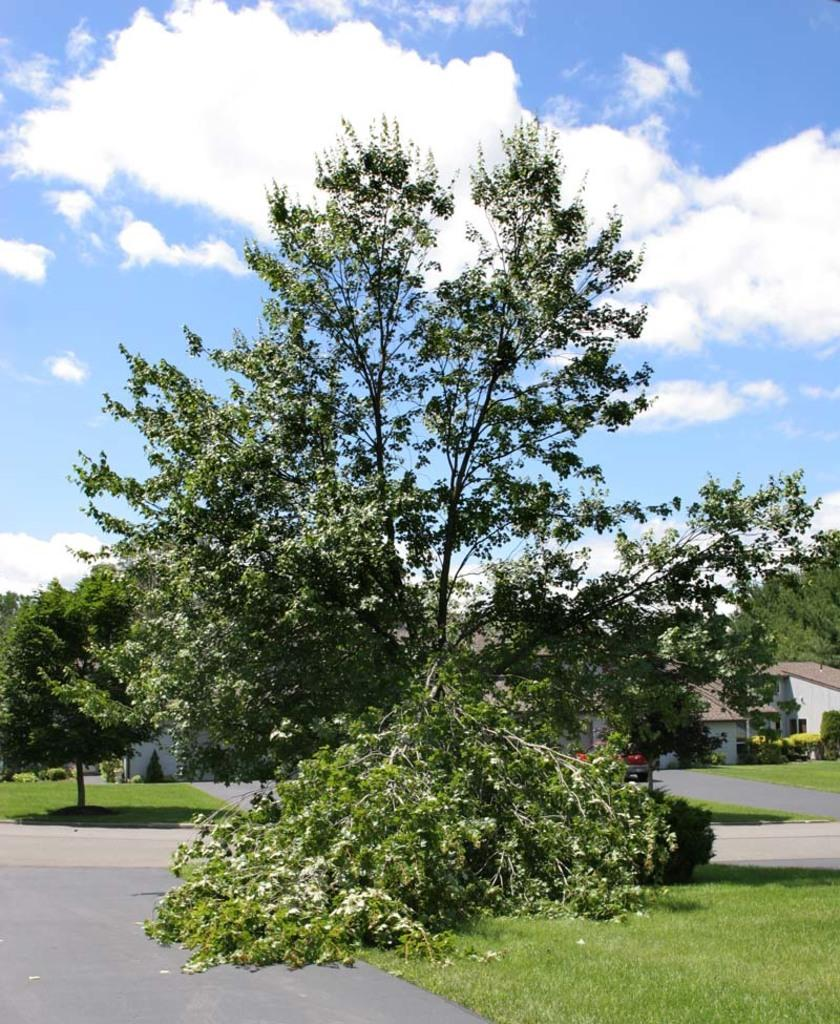What type of vegetation is present on the ground in the image? There is grass on the ground in the front of the image. What can be seen in the background of the image? There are trees and buildings in the background of the image. What is the condition of the sky in the image? The sky is cloudy in the image. How many pizzas are being served at the harbor in the image? There is no harbor or pizzas present in the image. Can you see a flame coming from the buildings in the image? There is no flame visible in the image; the buildings are not on fire. 